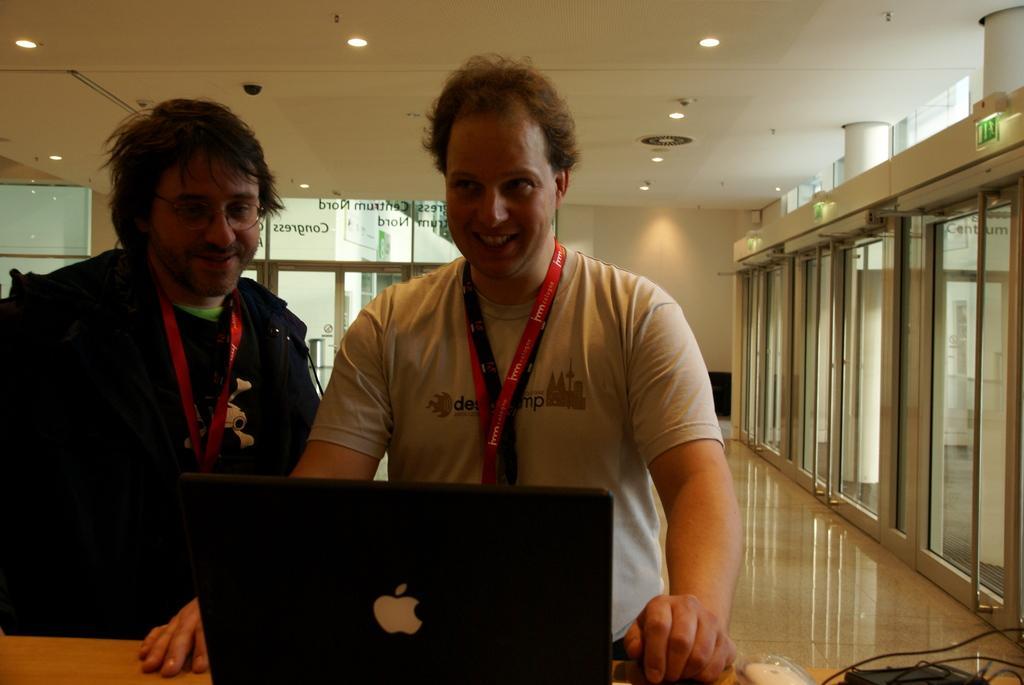Please provide a concise description of this image. In this image we can see two men. We can see tags around their necks. At the bottom of the image, we can see a laptop, wires and objects on the wooden surface. In the background, we can see glass, wall and door. At the top of the image, we can see the roof and lights. We can see floor in the right bottom of the image. 